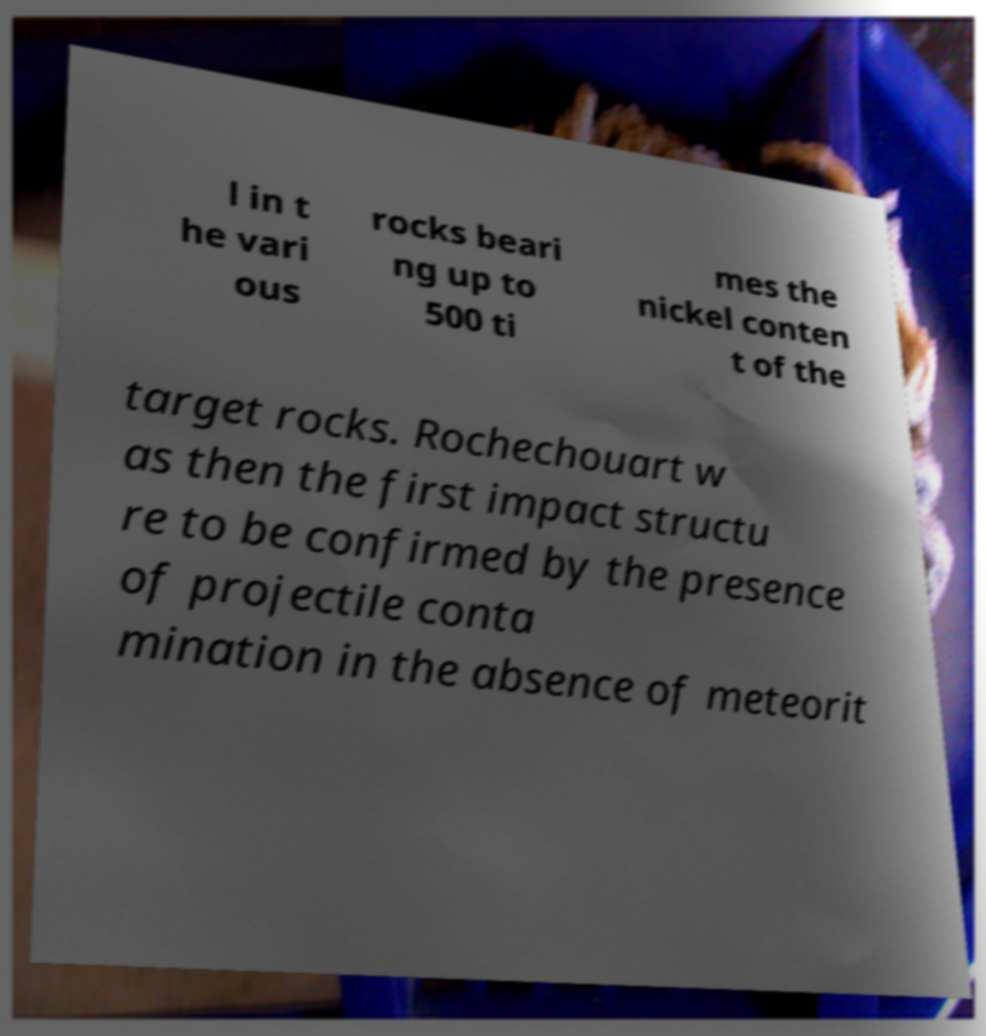For documentation purposes, I need the text within this image transcribed. Could you provide that? l in t he vari ous rocks beari ng up to 500 ti mes the nickel conten t of the target rocks. Rochechouart w as then the first impact structu re to be confirmed by the presence of projectile conta mination in the absence of meteorit 